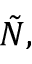Convert formula to latex. <formula><loc_0><loc_0><loc_500><loc_500>\tilde { N } ,</formula> 